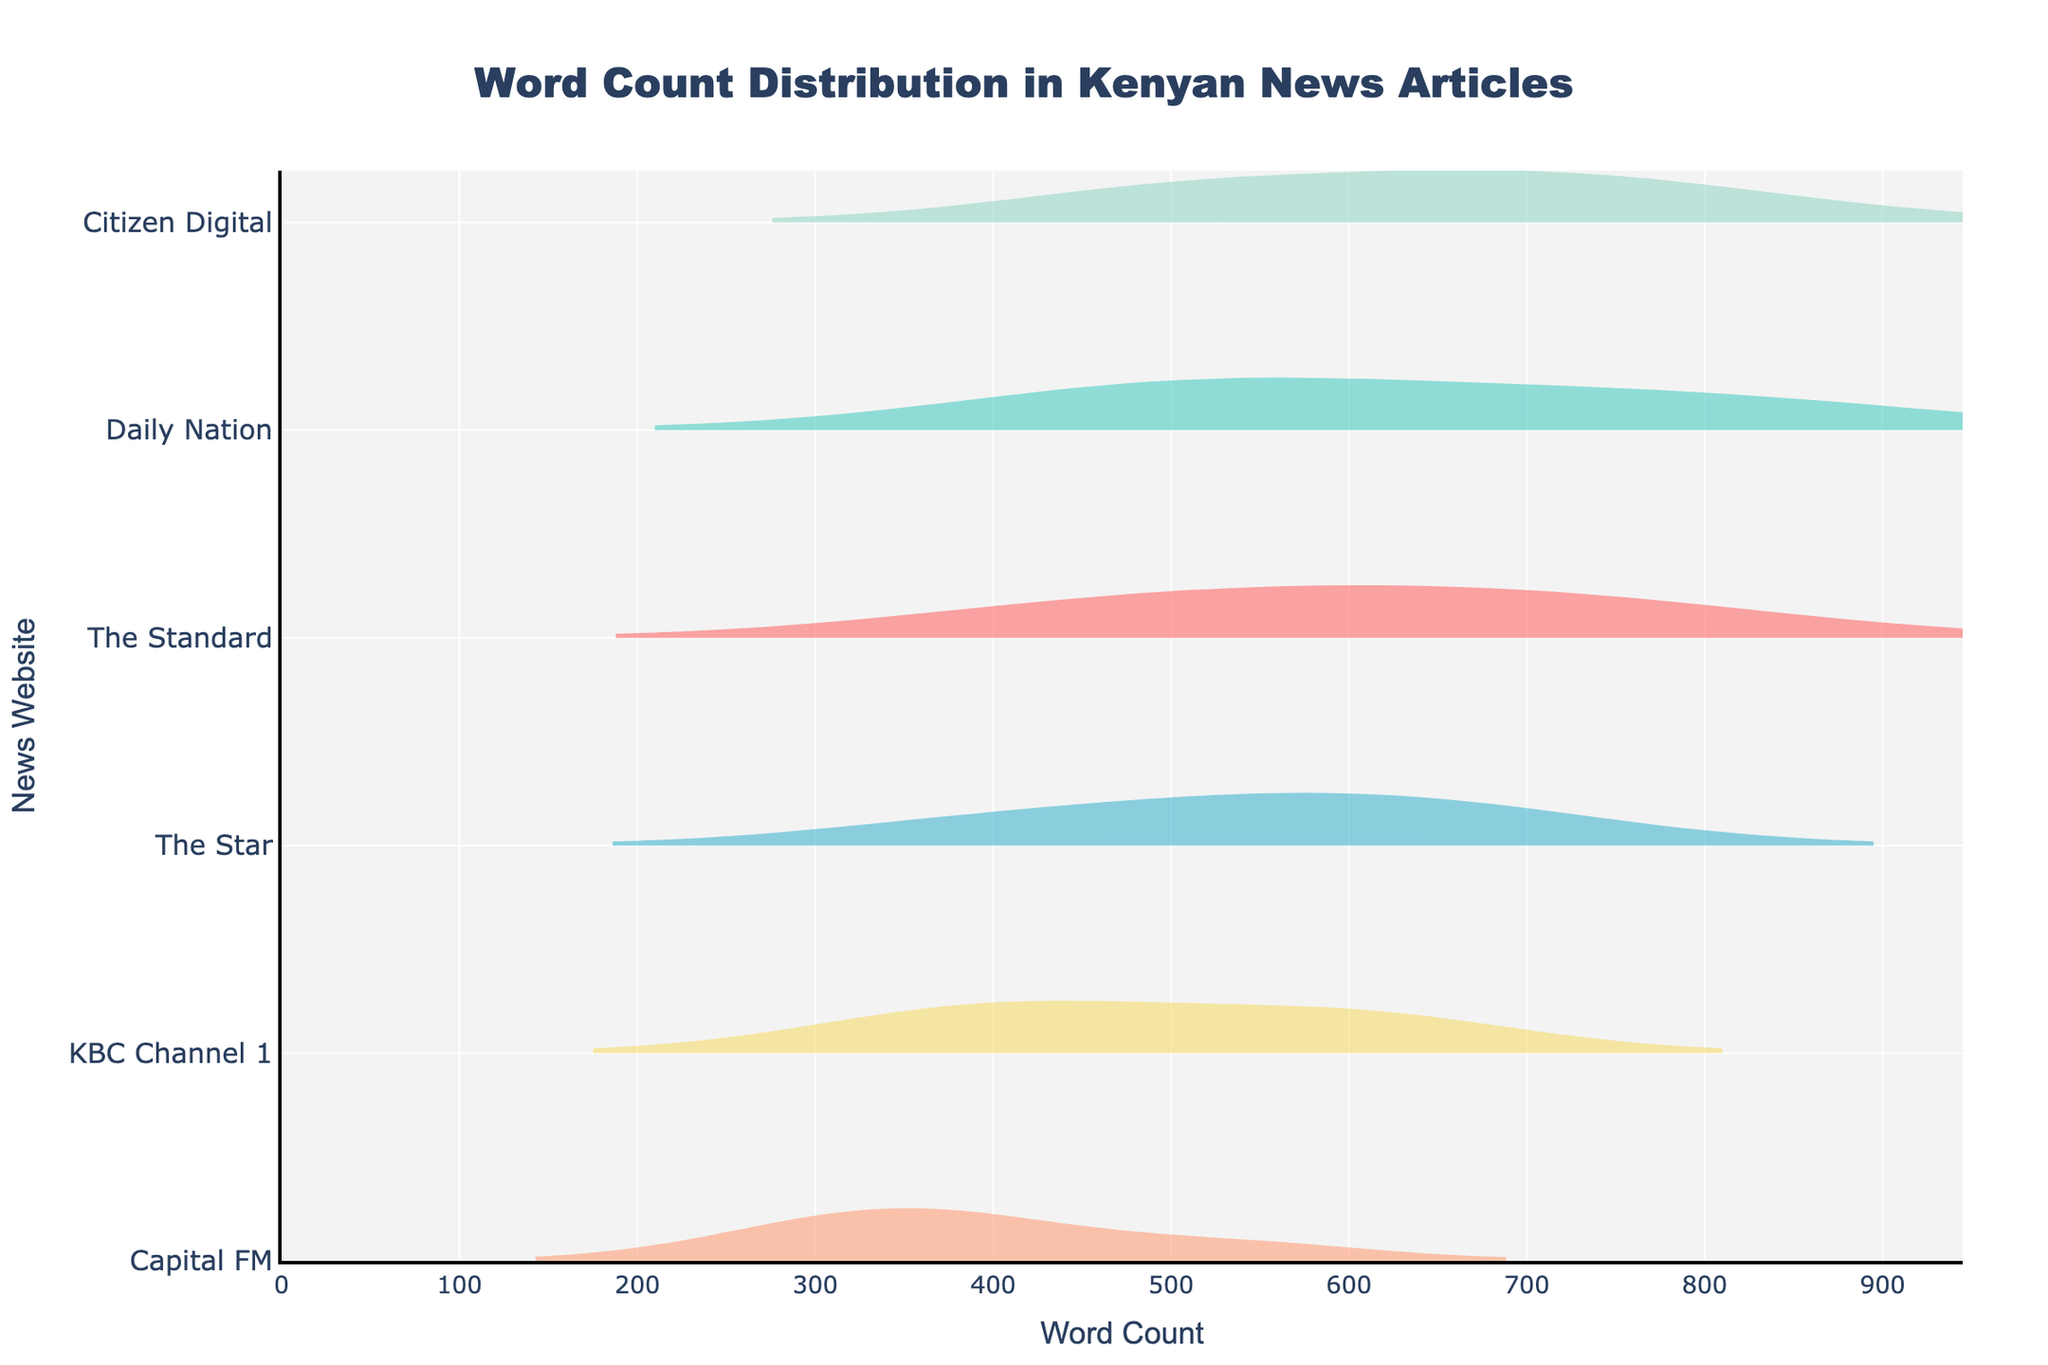What is the title of the figure? The title is positioned at the top center of the figure. It provides a summary of what the plot is about.
Answer: Word Count Distribution in Kenyan News Articles How many websites are represented in the plot? The y-axis displays the names of the news websites. Counting the unique entries gives the number of websites.
Answer: 6 Which website has the highest average word count? By examining the distribution and mean lines on the violin plots, the website with the highest mean line indicates the highest average word count.
Answer: Citizen Digital Which website has the widest range of word counts? The website with the most spread-out distribution (represented by the length of the violin plot) has the widest word count range.
Answer: Daily Nation What is the approximate word count range for Capital FM? Look at the spread (length) of the violin plot corresponding to Capital FM. Estimate the range from the start to end points of the plot.
Answer: 289 to 542 What is the average word count for articles from The Standard? Identify the mean line on The Standard's violin plot. The position of this line indicates the average word count.
Answer: Approximately 600 Which website has the most consistently sized articles, based on word count distribution? The website with the least spread in its violin plot (narrowest distribution) suggests more consistency in article length.
Answer: Capital FM Which website shows a word count distribution skewing towards higher length articles? The violin plot with a wider spread towards higher word counts shows a skew towards longer articles.
Answer: Citizen Digital Is there any website whose articles rarely exceed 500 words? Check the maximum boundaries of the violin plots to see if any plot rarely extends past 500 words.
Answer: Capital FM Which website has articles with the most variability in word count? The variability in word count is indicated by the spread and dispersion of the violin plot. The widest plot suggests the most variability.
Answer: Daily Nation 